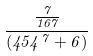<formula> <loc_0><loc_0><loc_500><loc_500>\frac { \frac { 7 } { 1 6 7 } } { ( 4 5 4 ^ { 7 } + 6 ) }</formula> 